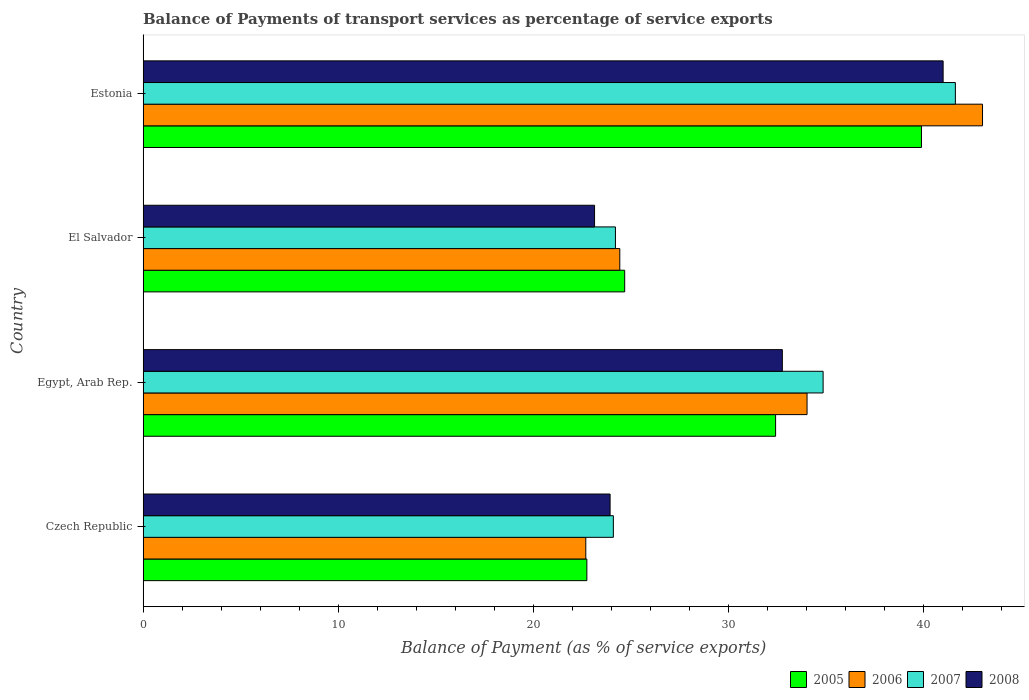How many different coloured bars are there?
Provide a succinct answer. 4. How many groups of bars are there?
Your answer should be very brief. 4. How many bars are there on the 2nd tick from the bottom?
Your response must be concise. 4. What is the label of the 2nd group of bars from the top?
Ensure brevity in your answer.  El Salvador. What is the balance of payments of transport services in 2007 in Estonia?
Provide a succinct answer. 41.62. Across all countries, what is the maximum balance of payments of transport services in 2006?
Provide a short and direct response. 43.01. Across all countries, what is the minimum balance of payments of transport services in 2006?
Your answer should be compact. 22.68. In which country was the balance of payments of transport services in 2006 maximum?
Provide a succinct answer. Estonia. In which country was the balance of payments of transport services in 2005 minimum?
Offer a terse response. Czech Republic. What is the total balance of payments of transport services in 2008 in the graph?
Offer a terse response. 120.81. What is the difference between the balance of payments of transport services in 2008 in Egypt, Arab Rep. and that in Estonia?
Your response must be concise. -8.24. What is the difference between the balance of payments of transport services in 2006 in Czech Republic and the balance of payments of transport services in 2007 in El Salvador?
Offer a very short reply. -1.52. What is the average balance of payments of transport services in 2006 per country?
Ensure brevity in your answer.  31.04. What is the difference between the balance of payments of transport services in 2008 and balance of payments of transport services in 2006 in El Salvador?
Ensure brevity in your answer.  -1.29. In how many countries, is the balance of payments of transport services in 2007 greater than 18 %?
Your response must be concise. 4. What is the ratio of the balance of payments of transport services in 2005 in Czech Republic to that in Estonia?
Your response must be concise. 0.57. What is the difference between the highest and the second highest balance of payments of transport services in 2005?
Ensure brevity in your answer.  7.47. What is the difference between the highest and the lowest balance of payments of transport services in 2008?
Your response must be concise. 17.86. Is the sum of the balance of payments of transport services in 2005 in Egypt, Arab Rep. and Estonia greater than the maximum balance of payments of transport services in 2007 across all countries?
Offer a terse response. Yes. What does the 1st bar from the top in Czech Republic represents?
Ensure brevity in your answer.  2008. What does the 3rd bar from the bottom in El Salvador represents?
Your response must be concise. 2007. Is it the case that in every country, the sum of the balance of payments of transport services in 2007 and balance of payments of transport services in 2006 is greater than the balance of payments of transport services in 2005?
Ensure brevity in your answer.  Yes. How many bars are there?
Your answer should be compact. 16. Does the graph contain any zero values?
Give a very brief answer. No. Does the graph contain grids?
Your answer should be very brief. No. How are the legend labels stacked?
Your answer should be compact. Horizontal. What is the title of the graph?
Offer a terse response. Balance of Payments of transport services as percentage of service exports. What is the label or title of the X-axis?
Your response must be concise. Balance of Payment (as % of service exports). What is the label or title of the Y-axis?
Your answer should be very brief. Country. What is the Balance of Payment (as % of service exports) in 2005 in Czech Republic?
Keep it short and to the point. 22.74. What is the Balance of Payment (as % of service exports) of 2006 in Czech Republic?
Your answer should be compact. 22.68. What is the Balance of Payment (as % of service exports) in 2007 in Czech Republic?
Your answer should be very brief. 24.1. What is the Balance of Payment (as % of service exports) in 2008 in Czech Republic?
Your answer should be compact. 23.93. What is the Balance of Payment (as % of service exports) in 2005 in Egypt, Arab Rep.?
Provide a succinct answer. 32.41. What is the Balance of Payment (as % of service exports) of 2006 in Egypt, Arab Rep.?
Offer a terse response. 34.02. What is the Balance of Payment (as % of service exports) in 2007 in Egypt, Arab Rep.?
Offer a very short reply. 34.84. What is the Balance of Payment (as % of service exports) in 2008 in Egypt, Arab Rep.?
Offer a terse response. 32.76. What is the Balance of Payment (as % of service exports) of 2005 in El Salvador?
Offer a terse response. 24.68. What is the Balance of Payment (as % of service exports) in 2006 in El Salvador?
Offer a very short reply. 24.43. What is the Balance of Payment (as % of service exports) of 2007 in El Salvador?
Provide a succinct answer. 24.2. What is the Balance of Payment (as % of service exports) of 2008 in El Salvador?
Give a very brief answer. 23.13. What is the Balance of Payment (as % of service exports) of 2005 in Estonia?
Keep it short and to the point. 39.88. What is the Balance of Payment (as % of service exports) of 2006 in Estonia?
Provide a short and direct response. 43.01. What is the Balance of Payment (as % of service exports) of 2007 in Estonia?
Give a very brief answer. 41.62. What is the Balance of Payment (as % of service exports) of 2008 in Estonia?
Offer a very short reply. 40.99. Across all countries, what is the maximum Balance of Payment (as % of service exports) in 2005?
Offer a very short reply. 39.88. Across all countries, what is the maximum Balance of Payment (as % of service exports) of 2006?
Provide a short and direct response. 43.01. Across all countries, what is the maximum Balance of Payment (as % of service exports) in 2007?
Make the answer very short. 41.62. Across all countries, what is the maximum Balance of Payment (as % of service exports) in 2008?
Your answer should be compact. 40.99. Across all countries, what is the minimum Balance of Payment (as % of service exports) of 2005?
Keep it short and to the point. 22.74. Across all countries, what is the minimum Balance of Payment (as % of service exports) in 2006?
Ensure brevity in your answer.  22.68. Across all countries, what is the minimum Balance of Payment (as % of service exports) in 2007?
Your answer should be very brief. 24.1. Across all countries, what is the minimum Balance of Payment (as % of service exports) in 2008?
Your answer should be very brief. 23.13. What is the total Balance of Payment (as % of service exports) in 2005 in the graph?
Offer a terse response. 119.71. What is the total Balance of Payment (as % of service exports) in 2006 in the graph?
Provide a short and direct response. 124.14. What is the total Balance of Payment (as % of service exports) of 2007 in the graph?
Offer a very short reply. 124.77. What is the total Balance of Payment (as % of service exports) in 2008 in the graph?
Your answer should be very brief. 120.81. What is the difference between the Balance of Payment (as % of service exports) in 2005 in Czech Republic and that in Egypt, Arab Rep.?
Offer a terse response. -9.67. What is the difference between the Balance of Payment (as % of service exports) in 2006 in Czech Republic and that in Egypt, Arab Rep.?
Provide a short and direct response. -11.34. What is the difference between the Balance of Payment (as % of service exports) of 2007 in Czech Republic and that in Egypt, Arab Rep.?
Give a very brief answer. -10.75. What is the difference between the Balance of Payment (as % of service exports) in 2008 in Czech Republic and that in Egypt, Arab Rep.?
Your answer should be compact. -8.83. What is the difference between the Balance of Payment (as % of service exports) of 2005 in Czech Republic and that in El Salvador?
Keep it short and to the point. -1.94. What is the difference between the Balance of Payment (as % of service exports) of 2006 in Czech Republic and that in El Salvador?
Make the answer very short. -1.74. What is the difference between the Balance of Payment (as % of service exports) in 2007 in Czech Republic and that in El Salvador?
Provide a short and direct response. -0.11. What is the difference between the Balance of Payment (as % of service exports) of 2008 in Czech Republic and that in El Salvador?
Make the answer very short. 0.8. What is the difference between the Balance of Payment (as % of service exports) of 2005 in Czech Republic and that in Estonia?
Ensure brevity in your answer.  -17.14. What is the difference between the Balance of Payment (as % of service exports) of 2006 in Czech Republic and that in Estonia?
Your answer should be compact. -20.33. What is the difference between the Balance of Payment (as % of service exports) of 2007 in Czech Republic and that in Estonia?
Your answer should be very brief. -17.52. What is the difference between the Balance of Payment (as % of service exports) of 2008 in Czech Republic and that in Estonia?
Make the answer very short. -17.06. What is the difference between the Balance of Payment (as % of service exports) in 2005 in Egypt, Arab Rep. and that in El Salvador?
Provide a succinct answer. 7.73. What is the difference between the Balance of Payment (as % of service exports) in 2006 in Egypt, Arab Rep. and that in El Salvador?
Provide a succinct answer. 9.59. What is the difference between the Balance of Payment (as % of service exports) of 2007 in Egypt, Arab Rep. and that in El Salvador?
Offer a very short reply. 10.64. What is the difference between the Balance of Payment (as % of service exports) of 2008 in Egypt, Arab Rep. and that in El Salvador?
Provide a succinct answer. 9.62. What is the difference between the Balance of Payment (as % of service exports) in 2005 in Egypt, Arab Rep. and that in Estonia?
Ensure brevity in your answer.  -7.47. What is the difference between the Balance of Payment (as % of service exports) in 2006 in Egypt, Arab Rep. and that in Estonia?
Provide a succinct answer. -8.99. What is the difference between the Balance of Payment (as % of service exports) of 2007 in Egypt, Arab Rep. and that in Estonia?
Offer a terse response. -6.78. What is the difference between the Balance of Payment (as % of service exports) of 2008 in Egypt, Arab Rep. and that in Estonia?
Your answer should be compact. -8.24. What is the difference between the Balance of Payment (as % of service exports) in 2005 in El Salvador and that in Estonia?
Ensure brevity in your answer.  -15.21. What is the difference between the Balance of Payment (as % of service exports) in 2006 in El Salvador and that in Estonia?
Offer a very short reply. -18.59. What is the difference between the Balance of Payment (as % of service exports) of 2007 in El Salvador and that in Estonia?
Ensure brevity in your answer.  -17.42. What is the difference between the Balance of Payment (as % of service exports) in 2008 in El Salvador and that in Estonia?
Give a very brief answer. -17.86. What is the difference between the Balance of Payment (as % of service exports) in 2005 in Czech Republic and the Balance of Payment (as % of service exports) in 2006 in Egypt, Arab Rep.?
Offer a very short reply. -11.28. What is the difference between the Balance of Payment (as % of service exports) in 2005 in Czech Republic and the Balance of Payment (as % of service exports) in 2007 in Egypt, Arab Rep.?
Your response must be concise. -12.1. What is the difference between the Balance of Payment (as % of service exports) in 2005 in Czech Republic and the Balance of Payment (as % of service exports) in 2008 in Egypt, Arab Rep.?
Give a very brief answer. -10.02. What is the difference between the Balance of Payment (as % of service exports) of 2006 in Czech Republic and the Balance of Payment (as % of service exports) of 2007 in Egypt, Arab Rep.?
Ensure brevity in your answer.  -12.16. What is the difference between the Balance of Payment (as % of service exports) of 2006 in Czech Republic and the Balance of Payment (as % of service exports) of 2008 in Egypt, Arab Rep.?
Offer a terse response. -10.07. What is the difference between the Balance of Payment (as % of service exports) in 2007 in Czech Republic and the Balance of Payment (as % of service exports) in 2008 in Egypt, Arab Rep.?
Provide a succinct answer. -8.66. What is the difference between the Balance of Payment (as % of service exports) of 2005 in Czech Republic and the Balance of Payment (as % of service exports) of 2006 in El Salvador?
Provide a short and direct response. -1.69. What is the difference between the Balance of Payment (as % of service exports) in 2005 in Czech Republic and the Balance of Payment (as % of service exports) in 2007 in El Salvador?
Provide a succinct answer. -1.46. What is the difference between the Balance of Payment (as % of service exports) of 2005 in Czech Republic and the Balance of Payment (as % of service exports) of 2008 in El Salvador?
Offer a very short reply. -0.39. What is the difference between the Balance of Payment (as % of service exports) in 2006 in Czech Republic and the Balance of Payment (as % of service exports) in 2007 in El Salvador?
Offer a very short reply. -1.52. What is the difference between the Balance of Payment (as % of service exports) in 2006 in Czech Republic and the Balance of Payment (as % of service exports) in 2008 in El Salvador?
Provide a short and direct response. -0.45. What is the difference between the Balance of Payment (as % of service exports) in 2007 in Czech Republic and the Balance of Payment (as % of service exports) in 2008 in El Salvador?
Your answer should be compact. 0.96. What is the difference between the Balance of Payment (as % of service exports) in 2005 in Czech Republic and the Balance of Payment (as % of service exports) in 2006 in Estonia?
Your response must be concise. -20.27. What is the difference between the Balance of Payment (as % of service exports) in 2005 in Czech Republic and the Balance of Payment (as % of service exports) in 2007 in Estonia?
Provide a succinct answer. -18.88. What is the difference between the Balance of Payment (as % of service exports) of 2005 in Czech Republic and the Balance of Payment (as % of service exports) of 2008 in Estonia?
Your answer should be very brief. -18.25. What is the difference between the Balance of Payment (as % of service exports) of 2006 in Czech Republic and the Balance of Payment (as % of service exports) of 2007 in Estonia?
Offer a terse response. -18.94. What is the difference between the Balance of Payment (as % of service exports) in 2006 in Czech Republic and the Balance of Payment (as % of service exports) in 2008 in Estonia?
Offer a very short reply. -18.31. What is the difference between the Balance of Payment (as % of service exports) in 2007 in Czech Republic and the Balance of Payment (as % of service exports) in 2008 in Estonia?
Give a very brief answer. -16.9. What is the difference between the Balance of Payment (as % of service exports) in 2005 in Egypt, Arab Rep. and the Balance of Payment (as % of service exports) in 2006 in El Salvador?
Provide a short and direct response. 7.98. What is the difference between the Balance of Payment (as % of service exports) in 2005 in Egypt, Arab Rep. and the Balance of Payment (as % of service exports) in 2007 in El Salvador?
Offer a very short reply. 8.21. What is the difference between the Balance of Payment (as % of service exports) in 2005 in Egypt, Arab Rep. and the Balance of Payment (as % of service exports) in 2008 in El Salvador?
Provide a succinct answer. 9.28. What is the difference between the Balance of Payment (as % of service exports) of 2006 in Egypt, Arab Rep. and the Balance of Payment (as % of service exports) of 2007 in El Salvador?
Your response must be concise. 9.82. What is the difference between the Balance of Payment (as % of service exports) of 2006 in Egypt, Arab Rep. and the Balance of Payment (as % of service exports) of 2008 in El Salvador?
Provide a succinct answer. 10.89. What is the difference between the Balance of Payment (as % of service exports) in 2007 in Egypt, Arab Rep. and the Balance of Payment (as % of service exports) in 2008 in El Salvador?
Your answer should be very brief. 11.71. What is the difference between the Balance of Payment (as % of service exports) of 2005 in Egypt, Arab Rep. and the Balance of Payment (as % of service exports) of 2006 in Estonia?
Your response must be concise. -10.6. What is the difference between the Balance of Payment (as % of service exports) of 2005 in Egypt, Arab Rep. and the Balance of Payment (as % of service exports) of 2007 in Estonia?
Your answer should be compact. -9.21. What is the difference between the Balance of Payment (as % of service exports) in 2005 in Egypt, Arab Rep. and the Balance of Payment (as % of service exports) in 2008 in Estonia?
Your response must be concise. -8.58. What is the difference between the Balance of Payment (as % of service exports) of 2006 in Egypt, Arab Rep. and the Balance of Payment (as % of service exports) of 2007 in Estonia?
Give a very brief answer. -7.6. What is the difference between the Balance of Payment (as % of service exports) in 2006 in Egypt, Arab Rep. and the Balance of Payment (as % of service exports) in 2008 in Estonia?
Your answer should be compact. -6.97. What is the difference between the Balance of Payment (as % of service exports) in 2007 in Egypt, Arab Rep. and the Balance of Payment (as % of service exports) in 2008 in Estonia?
Provide a succinct answer. -6.15. What is the difference between the Balance of Payment (as % of service exports) of 2005 in El Salvador and the Balance of Payment (as % of service exports) of 2006 in Estonia?
Provide a succinct answer. -18.33. What is the difference between the Balance of Payment (as % of service exports) in 2005 in El Salvador and the Balance of Payment (as % of service exports) in 2007 in Estonia?
Your response must be concise. -16.94. What is the difference between the Balance of Payment (as % of service exports) of 2005 in El Salvador and the Balance of Payment (as % of service exports) of 2008 in Estonia?
Offer a very short reply. -16.32. What is the difference between the Balance of Payment (as % of service exports) in 2006 in El Salvador and the Balance of Payment (as % of service exports) in 2007 in Estonia?
Your response must be concise. -17.19. What is the difference between the Balance of Payment (as % of service exports) of 2006 in El Salvador and the Balance of Payment (as % of service exports) of 2008 in Estonia?
Offer a very short reply. -16.57. What is the difference between the Balance of Payment (as % of service exports) of 2007 in El Salvador and the Balance of Payment (as % of service exports) of 2008 in Estonia?
Offer a very short reply. -16.79. What is the average Balance of Payment (as % of service exports) of 2005 per country?
Give a very brief answer. 29.93. What is the average Balance of Payment (as % of service exports) in 2006 per country?
Your answer should be compact. 31.04. What is the average Balance of Payment (as % of service exports) in 2007 per country?
Your response must be concise. 31.19. What is the average Balance of Payment (as % of service exports) of 2008 per country?
Make the answer very short. 30.2. What is the difference between the Balance of Payment (as % of service exports) in 2005 and Balance of Payment (as % of service exports) in 2006 in Czech Republic?
Provide a short and direct response. 0.05. What is the difference between the Balance of Payment (as % of service exports) of 2005 and Balance of Payment (as % of service exports) of 2007 in Czech Republic?
Provide a succinct answer. -1.36. What is the difference between the Balance of Payment (as % of service exports) in 2005 and Balance of Payment (as % of service exports) in 2008 in Czech Republic?
Offer a very short reply. -1.19. What is the difference between the Balance of Payment (as % of service exports) of 2006 and Balance of Payment (as % of service exports) of 2007 in Czech Republic?
Your answer should be very brief. -1.41. What is the difference between the Balance of Payment (as % of service exports) of 2006 and Balance of Payment (as % of service exports) of 2008 in Czech Republic?
Provide a succinct answer. -1.24. What is the difference between the Balance of Payment (as % of service exports) of 2007 and Balance of Payment (as % of service exports) of 2008 in Czech Republic?
Your answer should be compact. 0.17. What is the difference between the Balance of Payment (as % of service exports) of 2005 and Balance of Payment (as % of service exports) of 2006 in Egypt, Arab Rep.?
Give a very brief answer. -1.61. What is the difference between the Balance of Payment (as % of service exports) of 2005 and Balance of Payment (as % of service exports) of 2007 in Egypt, Arab Rep.?
Ensure brevity in your answer.  -2.43. What is the difference between the Balance of Payment (as % of service exports) of 2005 and Balance of Payment (as % of service exports) of 2008 in Egypt, Arab Rep.?
Your response must be concise. -0.35. What is the difference between the Balance of Payment (as % of service exports) in 2006 and Balance of Payment (as % of service exports) in 2007 in Egypt, Arab Rep.?
Provide a succinct answer. -0.82. What is the difference between the Balance of Payment (as % of service exports) of 2006 and Balance of Payment (as % of service exports) of 2008 in Egypt, Arab Rep.?
Make the answer very short. 1.27. What is the difference between the Balance of Payment (as % of service exports) of 2007 and Balance of Payment (as % of service exports) of 2008 in Egypt, Arab Rep.?
Your answer should be very brief. 2.09. What is the difference between the Balance of Payment (as % of service exports) in 2005 and Balance of Payment (as % of service exports) in 2006 in El Salvador?
Your answer should be very brief. 0.25. What is the difference between the Balance of Payment (as % of service exports) in 2005 and Balance of Payment (as % of service exports) in 2007 in El Salvador?
Keep it short and to the point. 0.47. What is the difference between the Balance of Payment (as % of service exports) in 2005 and Balance of Payment (as % of service exports) in 2008 in El Salvador?
Offer a terse response. 1.54. What is the difference between the Balance of Payment (as % of service exports) of 2006 and Balance of Payment (as % of service exports) of 2007 in El Salvador?
Offer a very short reply. 0.22. What is the difference between the Balance of Payment (as % of service exports) of 2006 and Balance of Payment (as % of service exports) of 2008 in El Salvador?
Make the answer very short. 1.29. What is the difference between the Balance of Payment (as % of service exports) in 2007 and Balance of Payment (as % of service exports) in 2008 in El Salvador?
Offer a terse response. 1.07. What is the difference between the Balance of Payment (as % of service exports) in 2005 and Balance of Payment (as % of service exports) in 2006 in Estonia?
Give a very brief answer. -3.13. What is the difference between the Balance of Payment (as % of service exports) in 2005 and Balance of Payment (as % of service exports) in 2007 in Estonia?
Offer a very short reply. -1.74. What is the difference between the Balance of Payment (as % of service exports) of 2005 and Balance of Payment (as % of service exports) of 2008 in Estonia?
Your answer should be compact. -1.11. What is the difference between the Balance of Payment (as % of service exports) of 2006 and Balance of Payment (as % of service exports) of 2007 in Estonia?
Keep it short and to the point. 1.39. What is the difference between the Balance of Payment (as % of service exports) of 2006 and Balance of Payment (as % of service exports) of 2008 in Estonia?
Provide a short and direct response. 2.02. What is the difference between the Balance of Payment (as % of service exports) of 2007 and Balance of Payment (as % of service exports) of 2008 in Estonia?
Give a very brief answer. 0.63. What is the ratio of the Balance of Payment (as % of service exports) in 2005 in Czech Republic to that in Egypt, Arab Rep.?
Your answer should be very brief. 0.7. What is the ratio of the Balance of Payment (as % of service exports) of 2006 in Czech Republic to that in Egypt, Arab Rep.?
Offer a very short reply. 0.67. What is the ratio of the Balance of Payment (as % of service exports) in 2007 in Czech Republic to that in Egypt, Arab Rep.?
Ensure brevity in your answer.  0.69. What is the ratio of the Balance of Payment (as % of service exports) of 2008 in Czech Republic to that in Egypt, Arab Rep.?
Offer a very short reply. 0.73. What is the ratio of the Balance of Payment (as % of service exports) in 2005 in Czech Republic to that in El Salvador?
Provide a short and direct response. 0.92. What is the ratio of the Balance of Payment (as % of service exports) in 2006 in Czech Republic to that in El Salvador?
Keep it short and to the point. 0.93. What is the ratio of the Balance of Payment (as % of service exports) of 2008 in Czech Republic to that in El Salvador?
Keep it short and to the point. 1.03. What is the ratio of the Balance of Payment (as % of service exports) in 2005 in Czech Republic to that in Estonia?
Provide a short and direct response. 0.57. What is the ratio of the Balance of Payment (as % of service exports) of 2006 in Czech Republic to that in Estonia?
Provide a succinct answer. 0.53. What is the ratio of the Balance of Payment (as % of service exports) in 2007 in Czech Republic to that in Estonia?
Keep it short and to the point. 0.58. What is the ratio of the Balance of Payment (as % of service exports) of 2008 in Czech Republic to that in Estonia?
Ensure brevity in your answer.  0.58. What is the ratio of the Balance of Payment (as % of service exports) of 2005 in Egypt, Arab Rep. to that in El Salvador?
Make the answer very short. 1.31. What is the ratio of the Balance of Payment (as % of service exports) of 2006 in Egypt, Arab Rep. to that in El Salvador?
Make the answer very short. 1.39. What is the ratio of the Balance of Payment (as % of service exports) in 2007 in Egypt, Arab Rep. to that in El Salvador?
Your answer should be compact. 1.44. What is the ratio of the Balance of Payment (as % of service exports) of 2008 in Egypt, Arab Rep. to that in El Salvador?
Provide a short and direct response. 1.42. What is the ratio of the Balance of Payment (as % of service exports) in 2005 in Egypt, Arab Rep. to that in Estonia?
Your answer should be compact. 0.81. What is the ratio of the Balance of Payment (as % of service exports) in 2006 in Egypt, Arab Rep. to that in Estonia?
Provide a succinct answer. 0.79. What is the ratio of the Balance of Payment (as % of service exports) of 2007 in Egypt, Arab Rep. to that in Estonia?
Provide a succinct answer. 0.84. What is the ratio of the Balance of Payment (as % of service exports) in 2008 in Egypt, Arab Rep. to that in Estonia?
Offer a terse response. 0.8. What is the ratio of the Balance of Payment (as % of service exports) of 2005 in El Salvador to that in Estonia?
Offer a very short reply. 0.62. What is the ratio of the Balance of Payment (as % of service exports) of 2006 in El Salvador to that in Estonia?
Your answer should be compact. 0.57. What is the ratio of the Balance of Payment (as % of service exports) of 2007 in El Salvador to that in Estonia?
Your answer should be compact. 0.58. What is the ratio of the Balance of Payment (as % of service exports) of 2008 in El Salvador to that in Estonia?
Your response must be concise. 0.56. What is the difference between the highest and the second highest Balance of Payment (as % of service exports) in 2005?
Your answer should be compact. 7.47. What is the difference between the highest and the second highest Balance of Payment (as % of service exports) of 2006?
Your answer should be very brief. 8.99. What is the difference between the highest and the second highest Balance of Payment (as % of service exports) of 2007?
Offer a terse response. 6.78. What is the difference between the highest and the second highest Balance of Payment (as % of service exports) of 2008?
Offer a terse response. 8.24. What is the difference between the highest and the lowest Balance of Payment (as % of service exports) of 2005?
Your answer should be compact. 17.14. What is the difference between the highest and the lowest Balance of Payment (as % of service exports) of 2006?
Ensure brevity in your answer.  20.33. What is the difference between the highest and the lowest Balance of Payment (as % of service exports) of 2007?
Give a very brief answer. 17.52. What is the difference between the highest and the lowest Balance of Payment (as % of service exports) of 2008?
Provide a short and direct response. 17.86. 